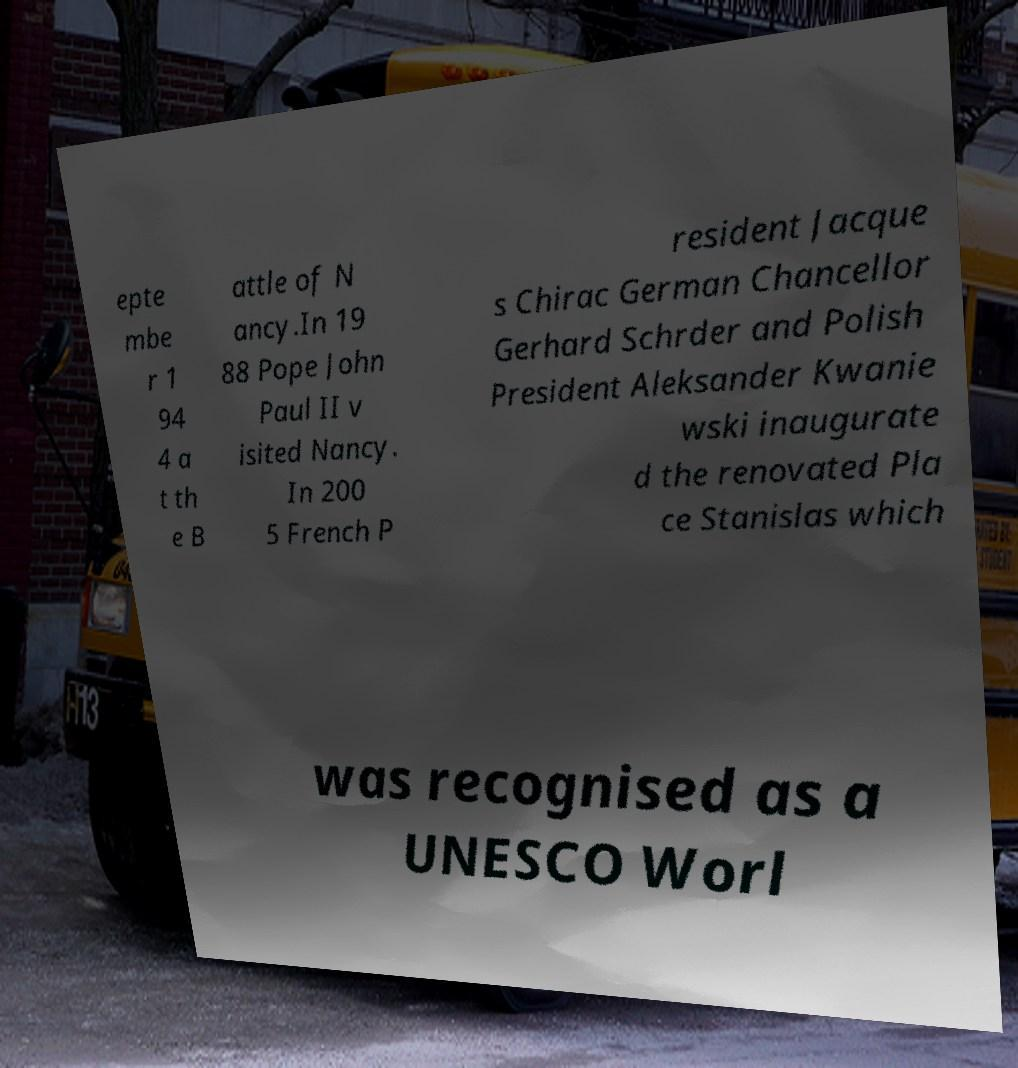Please identify and transcribe the text found in this image. epte mbe r 1 94 4 a t th e B attle of N ancy.In 19 88 Pope John Paul II v isited Nancy. In 200 5 French P resident Jacque s Chirac German Chancellor Gerhard Schrder and Polish President Aleksander Kwanie wski inaugurate d the renovated Pla ce Stanislas which was recognised as a UNESCO Worl 